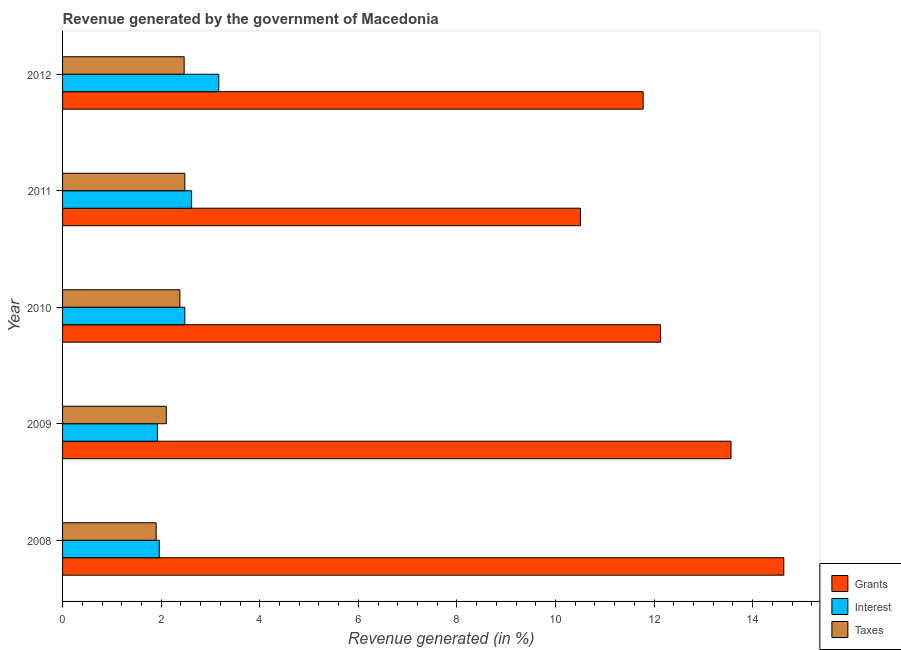How many groups of bars are there?
Your response must be concise. 5. What is the label of the 4th group of bars from the top?
Your answer should be compact. 2009. In how many cases, is the number of bars for a given year not equal to the number of legend labels?
Provide a succinct answer. 0. What is the percentage of revenue generated by interest in 2011?
Keep it short and to the point. 2.62. Across all years, what is the maximum percentage of revenue generated by grants?
Ensure brevity in your answer.  14.63. Across all years, what is the minimum percentage of revenue generated by interest?
Offer a very short reply. 1.92. In which year was the percentage of revenue generated by interest maximum?
Your answer should be very brief. 2012. What is the total percentage of revenue generated by interest in the graph?
Provide a succinct answer. 12.15. What is the difference between the percentage of revenue generated by interest in 2010 and that in 2012?
Offer a terse response. -0.69. What is the difference between the percentage of revenue generated by interest in 2008 and the percentage of revenue generated by grants in 2011?
Make the answer very short. -8.54. What is the average percentage of revenue generated by taxes per year?
Make the answer very short. 2.27. In the year 2008, what is the difference between the percentage of revenue generated by interest and percentage of revenue generated by taxes?
Give a very brief answer. 0.06. What is the ratio of the percentage of revenue generated by grants in 2008 to that in 2010?
Give a very brief answer. 1.21. Is the difference between the percentage of revenue generated by interest in 2010 and 2011 greater than the difference between the percentage of revenue generated by grants in 2010 and 2011?
Provide a short and direct response. No. What is the difference between the highest and the second highest percentage of revenue generated by interest?
Offer a terse response. 0.55. What is the difference between the highest and the lowest percentage of revenue generated by grants?
Your answer should be very brief. 4.12. In how many years, is the percentage of revenue generated by taxes greater than the average percentage of revenue generated by taxes taken over all years?
Offer a very short reply. 3. Is the sum of the percentage of revenue generated by grants in 2008 and 2009 greater than the maximum percentage of revenue generated by interest across all years?
Ensure brevity in your answer.  Yes. What does the 3rd bar from the top in 2008 represents?
Your response must be concise. Grants. What does the 1st bar from the bottom in 2008 represents?
Provide a succinct answer. Grants. How many bars are there?
Make the answer very short. 15. What is the difference between two consecutive major ticks on the X-axis?
Ensure brevity in your answer.  2. Are the values on the major ticks of X-axis written in scientific E-notation?
Your answer should be compact. No. Does the graph contain grids?
Your response must be concise. No. Where does the legend appear in the graph?
Ensure brevity in your answer.  Bottom right. What is the title of the graph?
Ensure brevity in your answer.  Revenue generated by the government of Macedonia. Does "Agriculture" appear as one of the legend labels in the graph?
Your response must be concise. No. What is the label or title of the X-axis?
Your response must be concise. Revenue generated (in %). What is the label or title of the Y-axis?
Your response must be concise. Year. What is the Revenue generated (in %) in Grants in 2008?
Your answer should be very brief. 14.63. What is the Revenue generated (in %) of Interest in 2008?
Your response must be concise. 1.96. What is the Revenue generated (in %) of Taxes in 2008?
Offer a terse response. 1.9. What is the Revenue generated (in %) of Grants in 2009?
Your answer should be very brief. 13.56. What is the Revenue generated (in %) of Interest in 2009?
Ensure brevity in your answer.  1.92. What is the Revenue generated (in %) in Taxes in 2009?
Offer a terse response. 2.1. What is the Revenue generated (in %) in Grants in 2010?
Provide a short and direct response. 12.13. What is the Revenue generated (in %) in Interest in 2010?
Your answer should be very brief. 2.48. What is the Revenue generated (in %) in Taxes in 2010?
Provide a short and direct response. 2.38. What is the Revenue generated (in %) of Grants in 2011?
Give a very brief answer. 10.51. What is the Revenue generated (in %) of Interest in 2011?
Provide a succinct answer. 2.62. What is the Revenue generated (in %) of Taxes in 2011?
Offer a terse response. 2.48. What is the Revenue generated (in %) of Grants in 2012?
Provide a short and direct response. 11.78. What is the Revenue generated (in %) of Interest in 2012?
Your response must be concise. 3.17. What is the Revenue generated (in %) in Taxes in 2012?
Give a very brief answer. 2.47. Across all years, what is the maximum Revenue generated (in %) in Grants?
Your response must be concise. 14.63. Across all years, what is the maximum Revenue generated (in %) of Interest?
Your answer should be compact. 3.17. Across all years, what is the maximum Revenue generated (in %) in Taxes?
Ensure brevity in your answer.  2.48. Across all years, what is the minimum Revenue generated (in %) of Grants?
Your answer should be compact. 10.51. Across all years, what is the minimum Revenue generated (in %) of Interest?
Offer a terse response. 1.92. Across all years, what is the minimum Revenue generated (in %) of Taxes?
Your answer should be compact. 1.9. What is the total Revenue generated (in %) of Grants in the graph?
Your answer should be compact. 62.61. What is the total Revenue generated (in %) in Interest in the graph?
Offer a terse response. 12.15. What is the total Revenue generated (in %) of Taxes in the graph?
Your answer should be very brief. 11.33. What is the difference between the Revenue generated (in %) of Grants in 2008 and that in 2009?
Your answer should be compact. 1.07. What is the difference between the Revenue generated (in %) in Interest in 2008 and that in 2009?
Make the answer very short. 0.04. What is the difference between the Revenue generated (in %) of Taxes in 2008 and that in 2009?
Offer a terse response. -0.21. What is the difference between the Revenue generated (in %) in Grants in 2008 and that in 2010?
Your answer should be compact. 2.5. What is the difference between the Revenue generated (in %) in Interest in 2008 and that in 2010?
Offer a very short reply. -0.52. What is the difference between the Revenue generated (in %) of Taxes in 2008 and that in 2010?
Provide a short and direct response. -0.48. What is the difference between the Revenue generated (in %) in Grants in 2008 and that in 2011?
Give a very brief answer. 4.12. What is the difference between the Revenue generated (in %) in Interest in 2008 and that in 2011?
Ensure brevity in your answer.  -0.66. What is the difference between the Revenue generated (in %) of Taxes in 2008 and that in 2011?
Offer a very short reply. -0.58. What is the difference between the Revenue generated (in %) of Grants in 2008 and that in 2012?
Keep it short and to the point. 2.85. What is the difference between the Revenue generated (in %) of Interest in 2008 and that in 2012?
Provide a short and direct response. -1.21. What is the difference between the Revenue generated (in %) of Taxes in 2008 and that in 2012?
Give a very brief answer. -0.57. What is the difference between the Revenue generated (in %) of Grants in 2009 and that in 2010?
Your answer should be compact. 1.43. What is the difference between the Revenue generated (in %) of Interest in 2009 and that in 2010?
Your answer should be compact. -0.56. What is the difference between the Revenue generated (in %) of Taxes in 2009 and that in 2010?
Give a very brief answer. -0.27. What is the difference between the Revenue generated (in %) of Grants in 2009 and that in 2011?
Give a very brief answer. 3.05. What is the difference between the Revenue generated (in %) of Interest in 2009 and that in 2011?
Your answer should be very brief. -0.69. What is the difference between the Revenue generated (in %) of Taxes in 2009 and that in 2011?
Keep it short and to the point. -0.38. What is the difference between the Revenue generated (in %) in Grants in 2009 and that in 2012?
Offer a terse response. 1.78. What is the difference between the Revenue generated (in %) in Interest in 2009 and that in 2012?
Ensure brevity in your answer.  -1.24. What is the difference between the Revenue generated (in %) of Taxes in 2009 and that in 2012?
Make the answer very short. -0.36. What is the difference between the Revenue generated (in %) in Grants in 2010 and that in 2011?
Offer a very short reply. 1.63. What is the difference between the Revenue generated (in %) of Interest in 2010 and that in 2011?
Give a very brief answer. -0.14. What is the difference between the Revenue generated (in %) of Taxes in 2010 and that in 2011?
Offer a very short reply. -0.1. What is the difference between the Revenue generated (in %) in Grants in 2010 and that in 2012?
Your answer should be very brief. 0.35. What is the difference between the Revenue generated (in %) of Interest in 2010 and that in 2012?
Provide a short and direct response. -0.69. What is the difference between the Revenue generated (in %) in Taxes in 2010 and that in 2012?
Make the answer very short. -0.09. What is the difference between the Revenue generated (in %) in Grants in 2011 and that in 2012?
Ensure brevity in your answer.  -1.27. What is the difference between the Revenue generated (in %) of Interest in 2011 and that in 2012?
Your answer should be compact. -0.55. What is the difference between the Revenue generated (in %) of Taxes in 2011 and that in 2012?
Give a very brief answer. 0.01. What is the difference between the Revenue generated (in %) of Grants in 2008 and the Revenue generated (in %) of Interest in 2009?
Offer a very short reply. 12.71. What is the difference between the Revenue generated (in %) in Grants in 2008 and the Revenue generated (in %) in Taxes in 2009?
Provide a succinct answer. 12.53. What is the difference between the Revenue generated (in %) in Interest in 2008 and the Revenue generated (in %) in Taxes in 2009?
Provide a short and direct response. -0.14. What is the difference between the Revenue generated (in %) in Grants in 2008 and the Revenue generated (in %) in Interest in 2010?
Provide a short and direct response. 12.15. What is the difference between the Revenue generated (in %) in Grants in 2008 and the Revenue generated (in %) in Taxes in 2010?
Your answer should be compact. 12.25. What is the difference between the Revenue generated (in %) of Interest in 2008 and the Revenue generated (in %) of Taxes in 2010?
Keep it short and to the point. -0.42. What is the difference between the Revenue generated (in %) of Grants in 2008 and the Revenue generated (in %) of Interest in 2011?
Your response must be concise. 12.01. What is the difference between the Revenue generated (in %) in Grants in 2008 and the Revenue generated (in %) in Taxes in 2011?
Keep it short and to the point. 12.15. What is the difference between the Revenue generated (in %) in Interest in 2008 and the Revenue generated (in %) in Taxes in 2011?
Your response must be concise. -0.52. What is the difference between the Revenue generated (in %) of Grants in 2008 and the Revenue generated (in %) of Interest in 2012?
Offer a very short reply. 11.46. What is the difference between the Revenue generated (in %) in Grants in 2008 and the Revenue generated (in %) in Taxes in 2012?
Keep it short and to the point. 12.16. What is the difference between the Revenue generated (in %) in Interest in 2008 and the Revenue generated (in %) in Taxes in 2012?
Offer a terse response. -0.5. What is the difference between the Revenue generated (in %) in Grants in 2009 and the Revenue generated (in %) in Interest in 2010?
Your answer should be compact. 11.08. What is the difference between the Revenue generated (in %) of Grants in 2009 and the Revenue generated (in %) of Taxes in 2010?
Your answer should be compact. 11.18. What is the difference between the Revenue generated (in %) of Interest in 2009 and the Revenue generated (in %) of Taxes in 2010?
Your answer should be very brief. -0.46. What is the difference between the Revenue generated (in %) of Grants in 2009 and the Revenue generated (in %) of Interest in 2011?
Provide a succinct answer. 10.94. What is the difference between the Revenue generated (in %) in Grants in 2009 and the Revenue generated (in %) in Taxes in 2011?
Offer a very short reply. 11.08. What is the difference between the Revenue generated (in %) of Interest in 2009 and the Revenue generated (in %) of Taxes in 2011?
Make the answer very short. -0.56. What is the difference between the Revenue generated (in %) of Grants in 2009 and the Revenue generated (in %) of Interest in 2012?
Your answer should be very brief. 10.39. What is the difference between the Revenue generated (in %) of Grants in 2009 and the Revenue generated (in %) of Taxes in 2012?
Ensure brevity in your answer.  11.09. What is the difference between the Revenue generated (in %) in Interest in 2009 and the Revenue generated (in %) in Taxes in 2012?
Your answer should be compact. -0.54. What is the difference between the Revenue generated (in %) of Grants in 2010 and the Revenue generated (in %) of Interest in 2011?
Give a very brief answer. 9.51. What is the difference between the Revenue generated (in %) in Grants in 2010 and the Revenue generated (in %) in Taxes in 2011?
Keep it short and to the point. 9.65. What is the difference between the Revenue generated (in %) in Interest in 2010 and the Revenue generated (in %) in Taxes in 2011?
Offer a very short reply. -0. What is the difference between the Revenue generated (in %) of Grants in 2010 and the Revenue generated (in %) of Interest in 2012?
Your answer should be compact. 8.96. What is the difference between the Revenue generated (in %) in Grants in 2010 and the Revenue generated (in %) in Taxes in 2012?
Provide a succinct answer. 9.66. What is the difference between the Revenue generated (in %) in Interest in 2010 and the Revenue generated (in %) in Taxes in 2012?
Your answer should be compact. 0.01. What is the difference between the Revenue generated (in %) of Grants in 2011 and the Revenue generated (in %) of Interest in 2012?
Offer a terse response. 7.34. What is the difference between the Revenue generated (in %) in Grants in 2011 and the Revenue generated (in %) in Taxes in 2012?
Your answer should be compact. 8.04. What is the difference between the Revenue generated (in %) in Interest in 2011 and the Revenue generated (in %) in Taxes in 2012?
Give a very brief answer. 0.15. What is the average Revenue generated (in %) of Grants per year?
Give a very brief answer. 12.52. What is the average Revenue generated (in %) of Interest per year?
Provide a succinct answer. 2.43. What is the average Revenue generated (in %) in Taxes per year?
Your answer should be compact. 2.27. In the year 2008, what is the difference between the Revenue generated (in %) in Grants and Revenue generated (in %) in Interest?
Ensure brevity in your answer.  12.67. In the year 2008, what is the difference between the Revenue generated (in %) of Grants and Revenue generated (in %) of Taxes?
Make the answer very short. 12.73. In the year 2008, what is the difference between the Revenue generated (in %) in Interest and Revenue generated (in %) in Taxes?
Give a very brief answer. 0.06. In the year 2009, what is the difference between the Revenue generated (in %) of Grants and Revenue generated (in %) of Interest?
Offer a terse response. 11.64. In the year 2009, what is the difference between the Revenue generated (in %) in Grants and Revenue generated (in %) in Taxes?
Keep it short and to the point. 11.46. In the year 2009, what is the difference between the Revenue generated (in %) in Interest and Revenue generated (in %) in Taxes?
Keep it short and to the point. -0.18. In the year 2010, what is the difference between the Revenue generated (in %) in Grants and Revenue generated (in %) in Interest?
Offer a terse response. 9.65. In the year 2010, what is the difference between the Revenue generated (in %) of Grants and Revenue generated (in %) of Taxes?
Keep it short and to the point. 9.75. In the year 2010, what is the difference between the Revenue generated (in %) in Interest and Revenue generated (in %) in Taxes?
Make the answer very short. 0.1. In the year 2011, what is the difference between the Revenue generated (in %) of Grants and Revenue generated (in %) of Interest?
Your answer should be very brief. 7.89. In the year 2011, what is the difference between the Revenue generated (in %) in Grants and Revenue generated (in %) in Taxes?
Your answer should be compact. 8.03. In the year 2011, what is the difference between the Revenue generated (in %) in Interest and Revenue generated (in %) in Taxes?
Make the answer very short. 0.14. In the year 2012, what is the difference between the Revenue generated (in %) of Grants and Revenue generated (in %) of Interest?
Give a very brief answer. 8.61. In the year 2012, what is the difference between the Revenue generated (in %) in Grants and Revenue generated (in %) in Taxes?
Make the answer very short. 9.31. In the year 2012, what is the difference between the Revenue generated (in %) in Interest and Revenue generated (in %) in Taxes?
Ensure brevity in your answer.  0.7. What is the ratio of the Revenue generated (in %) of Grants in 2008 to that in 2009?
Make the answer very short. 1.08. What is the ratio of the Revenue generated (in %) of Interest in 2008 to that in 2009?
Your answer should be compact. 1.02. What is the ratio of the Revenue generated (in %) of Taxes in 2008 to that in 2009?
Keep it short and to the point. 0.9. What is the ratio of the Revenue generated (in %) of Grants in 2008 to that in 2010?
Keep it short and to the point. 1.21. What is the ratio of the Revenue generated (in %) in Interest in 2008 to that in 2010?
Make the answer very short. 0.79. What is the ratio of the Revenue generated (in %) of Taxes in 2008 to that in 2010?
Make the answer very short. 0.8. What is the ratio of the Revenue generated (in %) in Grants in 2008 to that in 2011?
Provide a succinct answer. 1.39. What is the ratio of the Revenue generated (in %) of Interest in 2008 to that in 2011?
Give a very brief answer. 0.75. What is the ratio of the Revenue generated (in %) of Taxes in 2008 to that in 2011?
Ensure brevity in your answer.  0.77. What is the ratio of the Revenue generated (in %) in Grants in 2008 to that in 2012?
Keep it short and to the point. 1.24. What is the ratio of the Revenue generated (in %) in Interest in 2008 to that in 2012?
Your response must be concise. 0.62. What is the ratio of the Revenue generated (in %) of Taxes in 2008 to that in 2012?
Offer a very short reply. 0.77. What is the ratio of the Revenue generated (in %) in Grants in 2009 to that in 2010?
Offer a terse response. 1.12. What is the ratio of the Revenue generated (in %) in Interest in 2009 to that in 2010?
Ensure brevity in your answer.  0.78. What is the ratio of the Revenue generated (in %) of Taxes in 2009 to that in 2010?
Offer a terse response. 0.88. What is the ratio of the Revenue generated (in %) in Grants in 2009 to that in 2011?
Make the answer very short. 1.29. What is the ratio of the Revenue generated (in %) in Interest in 2009 to that in 2011?
Your response must be concise. 0.73. What is the ratio of the Revenue generated (in %) of Taxes in 2009 to that in 2011?
Provide a short and direct response. 0.85. What is the ratio of the Revenue generated (in %) in Grants in 2009 to that in 2012?
Make the answer very short. 1.15. What is the ratio of the Revenue generated (in %) of Interest in 2009 to that in 2012?
Provide a succinct answer. 0.61. What is the ratio of the Revenue generated (in %) of Taxes in 2009 to that in 2012?
Your response must be concise. 0.85. What is the ratio of the Revenue generated (in %) in Grants in 2010 to that in 2011?
Provide a succinct answer. 1.15. What is the ratio of the Revenue generated (in %) in Interest in 2010 to that in 2011?
Offer a terse response. 0.95. What is the ratio of the Revenue generated (in %) in Taxes in 2010 to that in 2011?
Provide a short and direct response. 0.96. What is the ratio of the Revenue generated (in %) in Grants in 2010 to that in 2012?
Provide a succinct answer. 1.03. What is the ratio of the Revenue generated (in %) in Interest in 2010 to that in 2012?
Offer a terse response. 0.78. What is the ratio of the Revenue generated (in %) of Taxes in 2010 to that in 2012?
Make the answer very short. 0.96. What is the ratio of the Revenue generated (in %) in Grants in 2011 to that in 2012?
Keep it short and to the point. 0.89. What is the ratio of the Revenue generated (in %) in Interest in 2011 to that in 2012?
Offer a terse response. 0.83. What is the ratio of the Revenue generated (in %) in Taxes in 2011 to that in 2012?
Offer a terse response. 1.01. What is the difference between the highest and the second highest Revenue generated (in %) of Grants?
Offer a terse response. 1.07. What is the difference between the highest and the second highest Revenue generated (in %) of Interest?
Your response must be concise. 0.55. What is the difference between the highest and the second highest Revenue generated (in %) of Taxes?
Keep it short and to the point. 0.01. What is the difference between the highest and the lowest Revenue generated (in %) in Grants?
Offer a very short reply. 4.12. What is the difference between the highest and the lowest Revenue generated (in %) in Interest?
Make the answer very short. 1.24. What is the difference between the highest and the lowest Revenue generated (in %) of Taxes?
Provide a short and direct response. 0.58. 